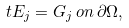Convert formula to latex. <formula><loc_0><loc_0><loc_500><loc_500>t E _ { j } = G _ { j } \, o n \, \partial \Omega ,</formula> 